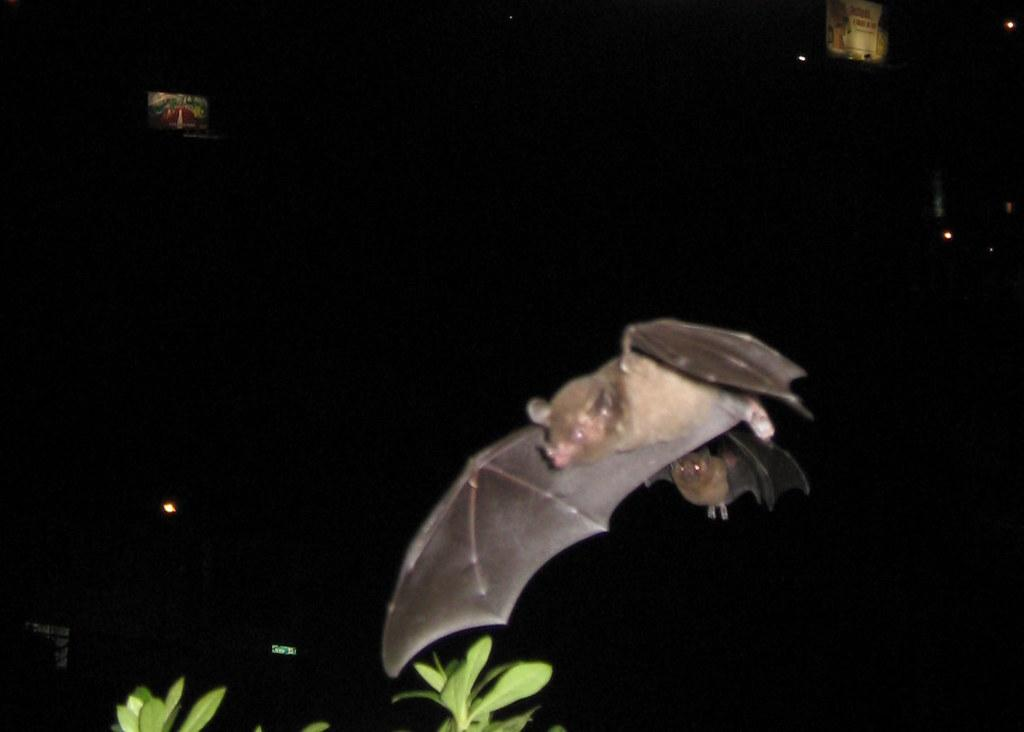What animal is present in the image? There is a bat in the image. What can be found at the bottom of the image? There are leaves at the bottom of the image. How many visitors can be seen interacting with the bat in the image? There are no visitors present in the image; it only features a bat and leaves. What type of ant is crawling on the bat in the image? There are no ants present in the image; it only features a bat and leaves. 